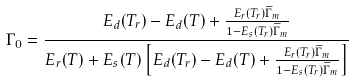<formula> <loc_0><loc_0><loc_500><loc_500>\Gamma _ { 0 } = \frac { E _ { d } ( T _ { r } ) - E _ { d } ( T ) + \frac { E _ { r } ( T _ { r } ) \widetilde { \Gamma } _ { m } } { 1 - E _ { s } ( T _ { r } ) \widetilde { \Gamma } _ { m } } } { E _ { r } ( T ) + E _ { s } ( T ) \left [ E _ { d } ( T _ { r } ) - E _ { d } ( T ) + \frac { E _ { r } ( T _ { r } ) \widetilde { \Gamma } _ { m } } { 1 - E _ { s } ( T _ { r } ) \widetilde { \Gamma } _ { m } } \right ] }</formula> 